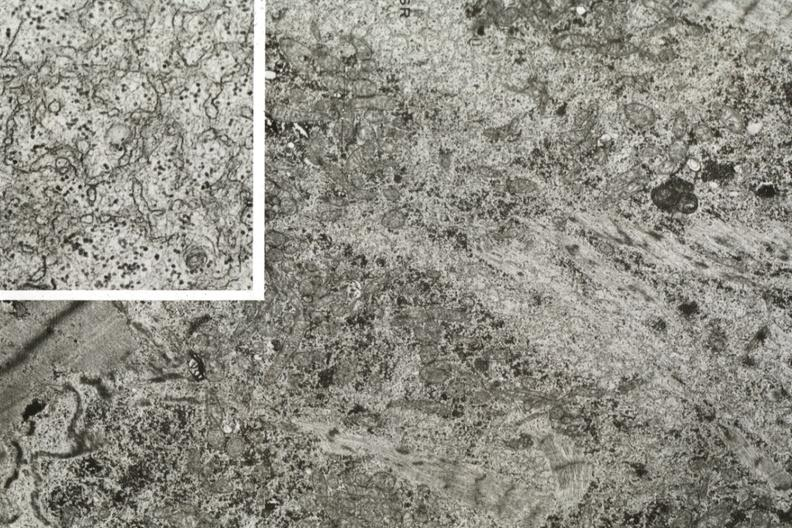where is this area in the body?
Answer the question using a single word or phrase. Heart 